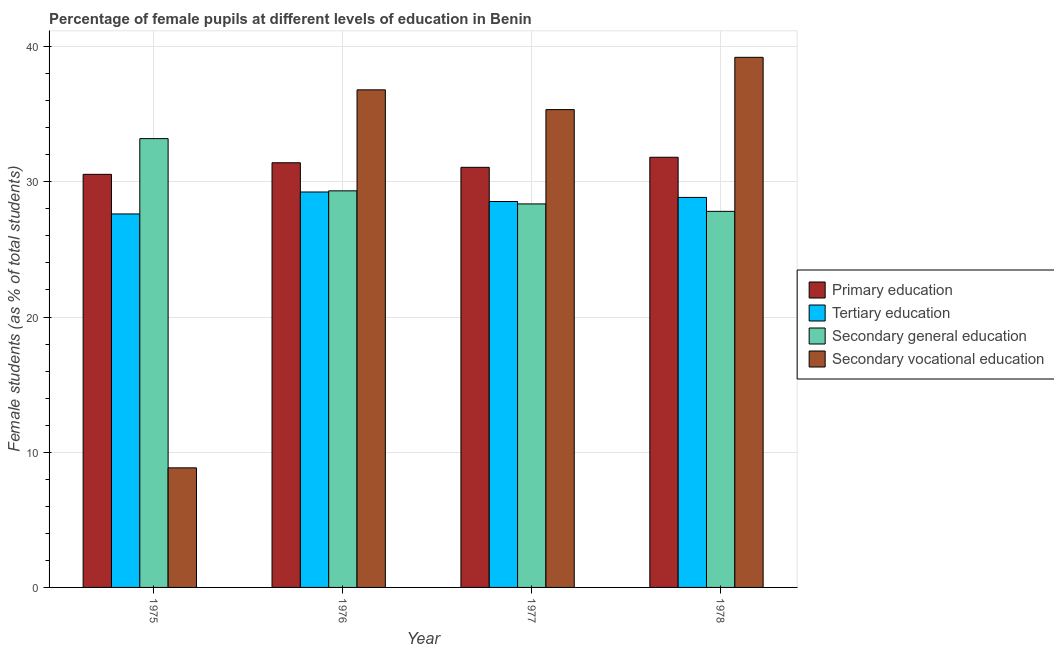How many different coloured bars are there?
Make the answer very short. 4. Are the number of bars per tick equal to the number of legend labels?
Ensure brevity in your answer.  Yes. How many bars are there on the 2nd tick from the left?
Your response must be concise. 4. What is the label of the 1st group of bars from the left?
Offer a very short reply. 1975. What is the percentage of female students in tertiary education in 1975?
Provide a short and direct response. 27.62. Across all years, what is the maximum percentage of female students in secondary vocational education?
Keep it short and to the point. 39.21. Across all years, what is the minimum percentage of female students in tertiary education?
Keep it short and to the point. 27.62. In which year was the percentage of female students in secondary vocational education maximum?
Provide a succinct answer. 1978. In which year was the percentage of female students in secondary vocational education minimum?
Provide a short and direct response. 1975. What is the total percentage of female students in secondary vocational education in the graph?
Keep it short and to the point. 120.19. What is the difference between the percentage of female students in tertiary education in 1976 and that in 1977?
Ensure brevity in your answer.  0.7. What is the difference between the percentage of female students in secondary vocational education in 1976 and the percentage of female students in secondary education in 1975?
Provide a succinct answer. 27.96. What is the average percentage of female students in primary education per year?
Keep it short and to the point. 31.21. In the year 1977, what is the difference between the percentage of female students in secondary education and percentage of female students in primary education?
Make the answer very short. 0. In how many years, is the percentage of female students in secondary vocational education greater than 16 %?
Your answer should be very brief. 3. What is the ratio of the percentage of female students in tertiary education in 1977 to that in 1978?
Keep it short and to the point. 0.99. Is the difference between the percentage of female students in primary education in 1975 and 1976 greater than the difference between the percentage of female students in secondary education in 1975 and 1976?
Keep it short and to the point. No. What is the difference between the highest and the second highest percentage of female students in primary education?
Give a very brief answer. 0.41. What is the difference between the highest and the lowest percentage of female students in secondary vocational education?
Keep it short and to the point. 30.36. In how many years, is the percentage of female students in secondary education greater than the average percentage of female students in secondary education taken over all years?
Ensure brevity in your answer.  1. What does the 3rd bar from the left in 1975 represents?
Provide a succinct answer. Secondary general education. What does the 4th bar from the right in 1978 represents?
Provide a short and direct response. Primary education. Is it the case that in every year, the sum of the percentage of female students in primary education and percentage of female students in tertiary education is greater than the percentage of female students in secondary education?
Provide a short and direct response. Yes. How many bars are there?
Offer a terse response. 16. Are the values on the major ticks of Y-axis written in scientific E-notation?
Ensure brevity in your answer.  No. Does the graph contain any zero values?
Make the answer very short. No. Does the graph contain grids?
Your answer should be very brief. Yes. Where does the legend appear in the graph?
Your answer should be very brief. Center right. How many legend labels are there?
Make the answer very short. 4. How are the legend labels stacked?
Keep it short and to the point. Vertical. What is the title of the graph?
Make the answer very short. Percentage of female pupils at different levels of education in Benin. What is the label or title of the Y-axis?
Keep it short and to the point. Female students (as % of total students). What is the Female students (as % of total students) in Primary education in 1975?
Provide a short and direct response. 30.55. What is the Female students (as % of total students) in Tertiary education in 1975?
Your response must be concise. 27.62. What is the Female students (as % of total students) in Secondary general education in 1975?
Offer a terse response. 33.19. What is the Female students (as % of total students) in Secondary vocational education in 1975?
Make the answer very short. 8.84. What is the Female students (as % of total students) in Primary education in 1976?
Keep it short and to the point. 31.41. What is the Female students (as % of total students) of Tertiary education in 1976?
Your response must be concise. 29.25. What is the Female students (as % of total students) of Secondary general education in 1976?
Ensure brevity in your answer.  29.33. What is the Female students (as % of total students) in Secondary vocational education in 1976?
Ensure brevity in your answer.  36.8. What is the Female students (as % of total students) of Primary education in 1977?
Your answer should be very brief. 31.07. What is the Female students (as % of total students) in Tertiary education in 1977?
Your answer should be compact. 28.54. What is the Female students (as % of total students) in Secondary general education in 1977?
Keep it short and to the point. 28.36. What is the Female students (as % of total students) in Secondary vocational education in 1977?
Provide a succinct answer. 35.34. What is the Female students (as % of total students) in Primary education in 1978?
Provide a succinct answer. 31.81. What is the Female students (as % of total students) in Tertiary education in 1978?
Offer a very short reply. 28.84. What is the Female students (as % of total students) in Secondary general education in 1978?
Ensure brevity in your answer.  27.81. What is the Female students (as % of total students) in Secondary vocational education in 1978?
Offer a terse response. 39.21. Across all years, what is the maximum Female students (as % of total students) of Primary education?
Provide a succinct answer. 31.81. Across all years, what is the maximum Female students (as % of total students) in Tertiary education?
Keep it short and to the point. 29.25. Across all years, what is the maximum Female students (as % of total students) in Secondary general education?
Make the answer very short. 33.19. Across all years, what is the maximum Female students (as % of total students) in Secondary vocational education?
Give a very brief answer. 39.21. Across all years, what is the minimum Female students (as % of total students) of Primary education?
Give a very brief answer. 30.55. Across all years, what is the minimum Female students (as % of total students) of Tertiary education?
Provide a succinct answer. 27.62. Across all years, what is the minimum Female students (as % of total students) in Secondary general education?
Your response must be concise. 27.81. Across all years, what is the minimum Female students (as % of total students) of Secondary vocational education?
Ensure brevity in your answer.  8.84. What is the total Female students (as % of total students) of Primary education in the graph?
Offer a very short reply. 124.85. What is the total Female students (as % of total students) of Tertiary education in the graph?
Your response must be concise. 114.26. What is the total Female students (as % of total students) of Secondary general education in the graph?
Your answer should be compact. 118.7. What is the total Female students (as % of total students) of Secondary vocational education in the graph?
Offer a terse response. 120.19. What is the difference between the Female students (as % of total students) of Primary education in 1975 and that in 1976?
Offer a very short reply. -0.86. What is the difference between the Female students (as % of total students) of Tertiary education in 1975 and that in 1976?
Keep it short and to the point. -1.62. What is the difference between the Female students (as % of total students) in Secondary general education in 1975 and that in 1976?
Offer a very short reply. 3.86. What is the difference between the Female students (as % of total students) in Secondary vocational education in 1975 and that in 1976?
Your answer should be very brief. -27.96. What is the difference between the Female students (as % of total students) in Primary education in 1975 and that in 1977?
Offer a terse response. -0.52. What is the difference between the Female students (as % of total students) of Tertiary education in 1975 and that in 1977?
Offer a very short reply. -0.92. What is the difference between the Female students (as % of total students) in Secondary general education in 1975 and that in 1977?
Provide a short and direct response. 4.83. What is the difference between the Female students (as % of total students) in Secondary vocational education in 1975 and that in 1977?
Ensure brevity in your answer.  -26.5. What is the difference between the Female students (as % of total students) in Primary education in 1975 and that in 1978?
Your response must be concise. -1.26. What is the difference between the Female students (as % of total students) in Tertiary education in 1975 and that in 1978?
Ensure brevity in your answer.  -1.22. What is the difference between the Female students (as % of total students) in Secondary general education in 1975 and that in 1978?
Give a very brief answer. 5.38. What is the difference between the Female students (as % of total students) of Secondary vocational education in 1975 and that in 1978?
Offer a terse response. -30.36. What is the difference between the Female students (as % of total students) of Primary education in 1976 and that in 1977?
Keep it short and to the point. 0.34. What is the difference between the Female students (as % of total students) of Tertiary education in 1976 and that in 1977?
Keep it short and to the point. 0.7. What is the difference between the Female students (as % of total students) in Secondary general education in 1976 and that in 1977?
Your response must be concise. 0.97. What is the difference between the Female students (as % of total students) in Secondary vocational education in 1976 and that in 1977?
Your answer should be compact. 1.46. What is the difference between the Female students (as % of total students) in Primary education in 1976 and that in 1978?
Keep it short and to the point. -0.41. What is the difference between the Female students (as % of total students) in Tertiary education in 1976 and that in 1978?
Keep it short and to the point. 0.4. What is the difference between the Female students (as % of total students) in Secondary general education in 1976 and that in 1978?
Offer a very short reply. 1.52. What is the difference between the Female students (as % of total students) in Secondary vocational education in 1976 and that in 1978?
Make the answer very short. -2.4. What is the difference between the Female students (as % of total students) of Primary education in 1977 and that in 1978?
Your answer should be very brief. -0.74. What is the difference between the Female students (as % of total students) in Tertiary education in 1977 and that in 1978?
Your answer should be compact. -0.3. What is the difference between the Female students (as % of total students) of Secondary general education in 1977 and that in 1978?
Offer a terse response. 0.55. What is the difference between the Female students (as % of total students) of Secondary vocational education in 1977 and that in 1978?
Provide a succinct answer. -3.87. What is the difference between the Female students (as % of total students) of Primary education in 1975 and the Female students (as % of total students) of Tertiary education in 1976?
Offer a terse response. 1.31. What is the difference between the Female students (as % of total students) of Primary education in 1975 and the Female students (as % of total students) of Secondary general education in 1976?
Your answer should be very brief. 1.22. What is the difference between the Female students (as % of total students) of Primary education in 1975 and the Female students (as % of total students) of Secondary vocational education in 1976?
Your answer should be very brief. -6.25. What is the difference between the Female students (as % of total students) of Tertiary education in 1975 and the Female students (as % of total students) of Secondary general education in 1976?
Provide a succinct answer. -1.71. What is the difference between the Female students (as % of total students) in Tertiary education in 1975 and the Female students (as % of total students) in Secondary vocational education in 1976?
Offer a very short reply. -9.18. What is the difference between the Female students (as % of total students) in Secondary general education in 1975 and the Female students (as % of total students) in Secondary vocational education in 1976?
Provide a succinct answer. -3.61. What is the difference between the Female students (as % of total students) in Primary education in 1975 and the Female students (as % of total students) in Tertiary education in 1977?
Your answer should be compact. 2.01. What is the difference between the Female students (as % of total students) of Primary education in 1975 and the Female students (as % of total students) of Secondary general education in 1977?
Your answer should be compact. 2.19. What is the difference between the Female students (as % of total students) of Primary education in 1975 and the Female students (as % of total students) of Secondary vocational education in 1977?
Make the answer very short. -4.79. What is the difference between the Female students (as % of total students) of Tertiary education in 1975 and the Female students (as % of total students) of Secondary general education in 1977?
Offer a very short reply. -0.74. What is the difference between the Female students (as % of total students) of Tertiary education in 1975 and the Female students (as % of total students) of Secondary vocational education in 1977?
Your response must be concise. -7.72. What is the difference between the Female students (as % of total students) of Secondary general education in 1975 and the Female students (as % of total students) of Secondary vocational education in 1977?
Keep it short and to the point. -2.15. What is the difference between the Female students (as % of total students) of Primary education in 1975 and the Female students (as % of total students) of Tertiary education in 1978?
Your answer should be very brief. 1.71. What is the difference between the Female students (as % of total students) of Primary education in 1975 and the Female students (as % of total students) of Secondary general education in 1978?
Keep it short and to the point. 2.74. What is the difference between the Female students (as % of total students) in Primary education in 1975 and the Female students (as % of total students) in Secondary vocational education in 1978?
Your answer should be compact. -8.65. What is the difference between the Female students (as % of total students) in Tertiary education in 1975 and the Female students (as % of total students) in Secondary general education in 1978?
Offer a terse response. -0.19. What is the difference between the Female students (as % of total students) of Tertiary education in 1975 and the Female students (as % of total students) of Secondary vocational education in 1978?
Ensure brevity in your answer.  -11.58. What is the difference between the Female students (as % of total students) in Secondary general education in 1975 and the Female students (as % of total students) in Secondary vocational education in 1978?
Offer a terse response. -6.01. What is the difference between the Female students (as % of total students) in Primary education in 1976 and the Female students (as % of total students) in Tertiary education in 1977?
Ensure brevity in your answer.  2.87. What is the difference between the Female students (as % of total students) in Primary education in 1976 and the Female students (as % of total students) in Secondary general education in 1977?
Make the answer very short. 3.04. What is the difference between the Female students (as % of total students) of Primary education in 1976 and the Female students (as % of total students) of Secondary vocational education in 1977?
Provide a short and direct response. -3.93. What is the difference between the Female students (as % of total students) in Tertiary education in 1976 and the Female students (as % of total students) in Secondary general education in 1977?
Make the answer very short. 0.88. What is the difference between the Female students (as % of total students) in Tertiary education in 1976 and the Female students (as % of total students) in Secondary vocational education in 1977?
Keep it short and to the point. -6.09. What is the difference between the Female students (as % of total students) in Secondary general education in 1976 and the Female students (as % of total students) in Secondary vocational education in 1977?
Offer a terse response. -6.01. What is the difference between the Female students (as % of total students) in Primary education in 1976 and the Female students (as % of total students) in Tertiary education in 1978?
Offer a terse response. 2.56. What is the difference between the Female students (as % of total students) in Primary education in 1976 and the Female students (as % of total students) in Secondary general education in 1978?
Make the answer very short. 3.59. What is the difference between the Female students (as % of total students) of Primary education in 1976 and the Female students (as % of total students) of Secondary vocational education in 1978?
Ensure brevity in your answer.  -7.8. What is the difference between the Female students (as % of total students) of Tertiary education in 1976 and the Female students (as % of total students) of Secondary general education in 1978?
Your response must be concise. 1.43. What is the difference between the Female students (as % of total students) in Tertiary education in 1976 and the Female students (as % of total students) in Secondary vocational education in 1978?
Provide a succinct answer. -9.96. What is the difference between the Female students (as % of total students) of Secondary general education in 1976 and the Female students (as % of total students) of Secondary vocational education in 1978?
Provide a short and direct response. -9.87. What is the difference between the Female students (as % of total students) in Primary education in 1977 and the Female students (as % of total students) in Tertiary education in 1978?
Provide a succinct answer. 2.23. What is the difference between the Female students (as % of total students) of Primary education in 1977 and the Female students (as % of total students) of Secondary general education in 1978?
Offer a terse response. 3.26. What is the difference between the Female students (as % of total students) of Primary education in 1977 and the Female students (as % of total students) of Secondary vocational education in 1978?
Give a very brief answer. -8.13. What is the difference between the Female students (as % of total students) of Tertiary education in 1977 and the Female students (as % of total students) of Secondary general education in 1978?
Provide a succinct answer. 0.73. What is the difference between the Female students (as % of total students) of Tertiary education in 1977 and the Female students (as % of total students) of Secondary vocational education in 1978?
Keep it short and to the point. -10.66. What is the difference between the Female students (as % of total students) in Secondary general education in 1977 and the Female students (as % of total students) in Secondary vocational education in 1978?
Make the answer very short. -10.84. What is the average Female students (as % of total students) of Primary education per year?
Make the answer very short. 31.21. What is the average Female students (as % of total students) of Tertiary education per year?
Provide a short and direct response. 28.56. What is the average Female students (as % of total students) in Secondary general education per year?
Your answer should be compact. 29.68. What is the average Female students (as % of total students) in Secondary vocational education per year?
Your response must be concise. 30.05. In the year 1975, what is the difference between the Female students (as % of total students) in Primary education and Female students (as % of total students) in Tertiary education?
Offer a very short reply. 2.93. In the year 1975, what is the difference between the Female students (as % of total students) in Primary education and Female students (as % of total students) in Secondary general education?
Ensure brevity in your answer.  -2.64. In the year 1975, what is the difference between the Female students (as % of total students) of Primary education and Female students (as % of total students) of Secondary vocational education?
Your answer should be compact. 21.71. In the year 1975, what is the difference between the Female students (as % of total students) in Tertiary education and Female students (as % of total students) in Secondary general education?
Ensure brevity in your answer.  -5.57. In the year 1975, what is the difference between the Female students (as % of total students) in Tertiary education and Female students (as % of total students) in Secondary vocational education?
Your answer should be very brief. 18.78. In the year 1975, what is the difference between the Female students (as % of total students) in Secondary general education and Female students (as % of total students) in Secondary vocational education?
Your answer should be compact. 24.35. In the year 1976, what is the difference between the Female students (as % of total students) in Primary education and Female students (as % of total students) in Tertiary education?
Your answer should be very brief. 2.16. In the year 1976, what is the difference between the Female students (as % of total students) in Primary education and Female students (as % of total students) in Secondary general education?
Offer a terse response. 2.08. In the year 1976, what is the difference between the Female students (as % of total students) in Primary education and Female students (as % of total students) in Secondary vocational education?
Your answer should be very brief. -5.39. In the year 1976, what is the difference between the Female students (as % of total students) in Tertiary education and Female students (as % of total students) in Secondary general education?
Your answer should be very brief. -0.08. In the year 1976, what is the difference between the Female students (as % of total students) in Tertiary education and Female students (as % of total students) in Secondary vocational education?
Provide a succinct answer. -7.55. In the year 1976, what is the difference between the Female students (as % of total students) of Secondary general education and Female students (as % of total students) of Secondary vocational education?
Your answer should be very brief. -7.47. In the year 1977, what is the difference between the Female students (as % of total students) in Primary education and Female students (as % of total students) in Tertiary education?
Offer a very short reply. 2.53. In the year 1977, what is the difference between the Female students (as % of total students) in Primary education and Female students (as % of total students) in Secondary general education?
Provide a short and direct response. 2.71. In the year 1977, what is the difference between the Female students (as % of total students) of Primary education and Female students (as % of total students) of Secondary vocational education?
Provide a short and direct response. -4.27. In the year 1977, what is the difference between the Female students (as % of total students) of Tertiary education and Female students (as % of total students) of Secondary general education?
Your answer should be very brief. 0.18. In the year 1977, what is the difference between the Female students (as % of total students) in Tertiary education and Female students (as % of total students) in Secondary vocational education?
Offer a terse response. -6.8. In the year 1977, what is the difference between the Female students (as % of total students) in Secondary general education and Female students (as % of total students) in Secondary vocational education?
Keep it short and to the point. -6.98. In the year 1978, what is the difference between the Female students (as % of total students) in Primary education and Female students (as % of total students) in Tertiary education?
Offer a terse response. 2.97. In the year 1978, what is the difference between the Female students (as % of total students) in Primary education and Female students (as % of total students) in Secondary general education?
Your answer should be very brief. 4. In the year 1978, what is the difference between the Female students (as % of total students) of Primary education and Female students (as % of total students) of Secondary vocational education?
Your answer should be compact. -7.39. In the year 1978, what is the difference between the Female students (as % of total students) in Tertiary education and Female students (as % of total students) in Secondary general education?
Provide a succinct answer. 1.03. In the year 1978, what is the difference between the Female students (as % of total students) in Tertiary education and Female students (as % of total students) in Secondary vocational education?
Your answer should be compact. -10.36. In the year 1978, what is the difference between the Female students (as % of total students) of Secondary general education and Female students (as % of total students) of Secondary vocational education?
Ensure brevity in your answer.  -11.39. What is the ratio of the Female students (as % of total students) in Primary education in 1975 to that in 1976?
Make the answer very short. 0.97. What is the ratio of the Female students (as % of total students) in Tertiary education in 1975 to that in 1976?
Your answer should be compact. 0.94. What is the ratio of the Female students (as % of total students) of Secondary general education in 1975 to that in 1976?
Your answer should be compact. 1.13. What is the ratio of the Female students (as % of total students) of Secondary vocational education in 1975 to that in 1976?
Provide a short and direct response. 0.24. What is the ratio of the Female students (as % of total students) of Primary education in 1975 to that in 1977?
Provide a short and direct response. 0.98. What is the ratio of the Female students (as % of total students) of Tertiary education in 1975 to that in 1977?
Ensure brevity in your answer.  0.97. What is the ratio of the Female students (as % of total students) of Secondary general education in 1975 to that in 1977?
Provide a short and direct response. 1.17. What is the ratio of the Female students (as % of total students) of Secondary vocational education in 1975 to that in 1977?
Provide a short and direct response. 0.25. What is the ratio of the Female students (as % of total students) of Primary education in 1975 to that in 1978?
Ensure brevity in your answer.  0.96. What is the ratio of the Female students (as % of total students) of Tertiary education in 1975 to that in 1978?
Ensure brevity in your answer.  0.96. What is the ratio of the Female students (as % of total students) in Secondary general education in 1975 to that in 1978?
Provide a succinct answer. 1.19. What is the ratio of the Female students (as % of total students) in Secondary vocational education in 1975 to that in 1978?
Keep it short and to the point. 0.23. What is the ratio of the Female students (as % of total students) in Primary education in 1976 to that in 1977?
Provide a short and direct response. 1.01. What is the ratio of the Female students (as % of total students) in Tertiary education in 1976 to that in 1977?
Your answer should be compact. 1.02. What is the ratio of the Female students (as % of total students) in Secondary general education in 1976 to that in 1977?
Keep it short and to the point. 1.03. What is the ratio of the Female students (as % of total students) in Secondary vocational education in 1976 to that in 1977?
Provide a short and direct response. 1.04. What is the ratio of the Female students (as % of total students) of Primary education in 1976 to that in 1978?
Your answer should be very brief. 0.99. What is the ratio of the Female students (as % of total students) in Tertiary education in 1976 to that in 1978?
Make the answer very short. 1.01. What is the ratio of the Female students (as % of total students) in Secondary general education in 1976 to that in 1978?
Your answer should be compact. 1.05. What is the ratio of the Female students (as % of total students) in Secondary vocational education in 1976 to that in 1978?
Ensure brevity in your answer.  0.94. What is the ratio of the Female students (as % of total students) in Primary education in 1977 to that in 1978?
Ensure brevity in your answer.  0.98. What is the ratio of the Female students (as % of total students) in Secondary general education in 1977 to that in 1978?
Ensure brevity in your answer.  1.02. What is the ratio of the Female students (as % of total students) in Secondary vocational education in 1977 to that in 1978?
Offer a terse response. 0.9. What is the difference between the highest and the second highest Female students (as % of total students) in Primary education?
Keep it short and to the point. 0.41. What is the difference between the highest and the second highest Female students (as % of total students) of Tertiary education?
Ensure brevity in your answer.  0.4. What is the difference between the highest and the second highest Female students (as % of total students) in Secondary general education?
Give a very brief answer. 3.86. What is the difference between the highest and the second highest Female students (as % of total students) of Secondary vocational education?
Your response must be concise. 2.4. What is the difference between the highest and the lowest Female students (as % of total students) of Primary education?
Ensure brevity in your answer.  1.26. What is the difference between the highest and the lowest Female students (as % of total students) in Tertiary education?
Provide a succinct answer. 1.62. What is the difference between the highest and the lowest Female students (as % of total students) of Secondary general education?
Keep it short and to the point. 5.38. What is the difference between the highest and the lowest Female students (as % of total students) of Secondary vocational education?
Ensure brevity in your answer.  30.36. 